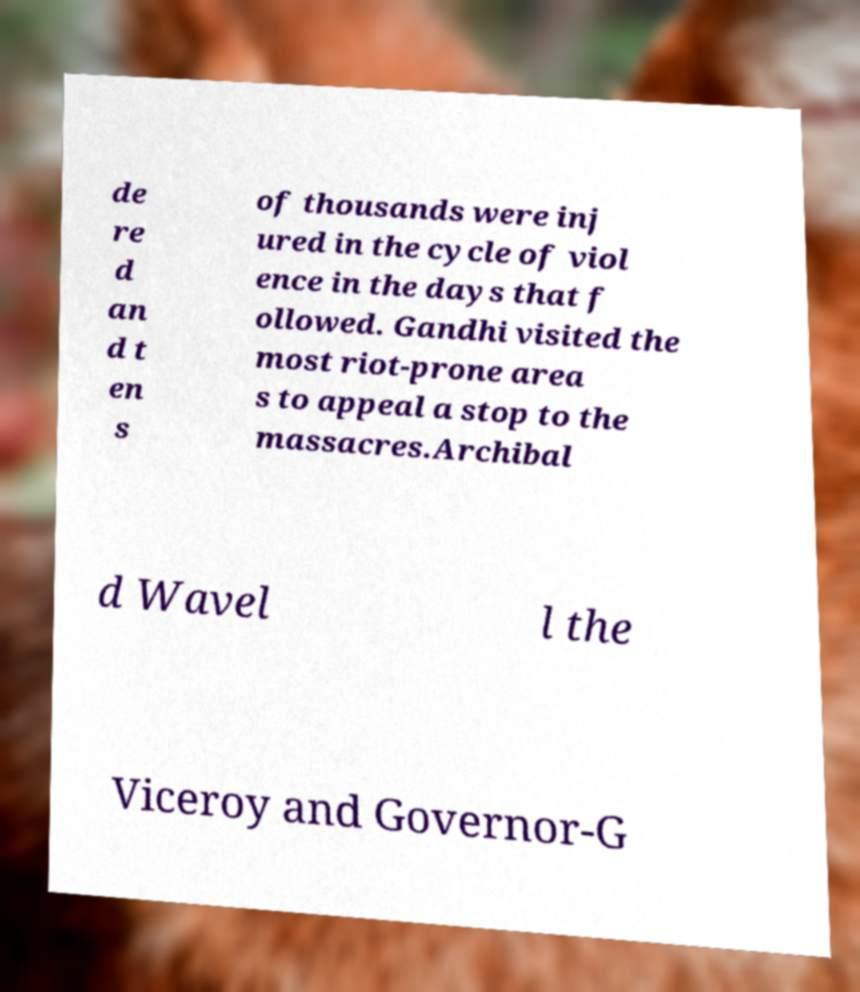I need the written content from this picture converted into text. Can you do that? de re d an d t en s of thousands were inj ured in the cycle of viol ence in the days that f ollowed. Gandhi visited the most riot-prone area s to appeal a stop to the massacres.Archibal d Wavel l the Viceroy and Governor-G 